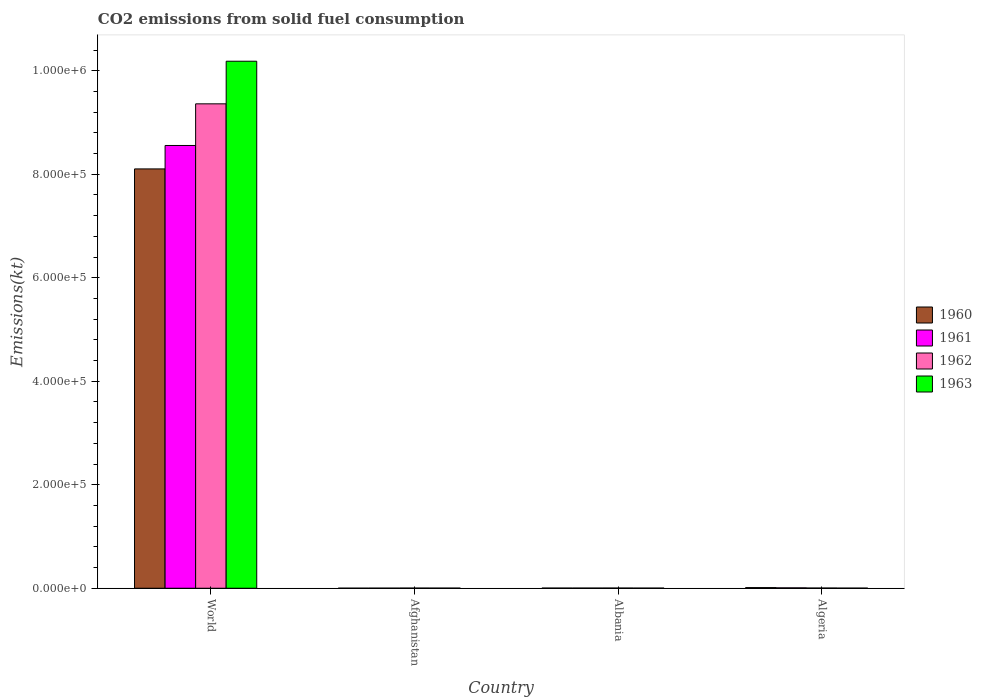How many groups of bars are there?
Keep it short and to the point. 4. Are the number of bars per tick equal to the number of legend labels?
Your answer should be compact. Yes. How many bars are there on the 1st tick from the left?
Make the answer very short. 4. How many bars are there on the 4th tick from the right?
Provide a short and direct response. 4. What is the label of the 2nd group of bars from the left?
Your response must be concise. Afghanistan. In how many cases, is the number of bars for a given country not equal to the number of legend labels?
Your response must be concise. 0. What is the amount of CO2 emitted in 1960 in Albania?
Provide a succinct answer. 326.36. Across all countries, what is the maximum amount of CO2 emitted in 1960?
Provide a short and direct response. 8.10e+05. Across all countries, what is the minimum amount of CO2 emitted in 1961?
Make the answer very short. 176.02. In which country was the amount of CO2 emitted in 1960 minimum?
Make the answer very short. Afghanistan. What is the total amount of CO2 emitted in 1960 in the graph?
Make the answer very short. 8.12e+05. What is the difference between the amount of CO2 emitted in 1960 in Afghanistan and that in Albania?
Ensure brevity in your answer.  -198.02. What is the difference between the amount of CO2 emitted in 1963 in Algeria and the amount of CO2 emitted in 1960 in Albania?
Your response must be concise. -73.34. What is the average amount of CO2 emitted in 1963 per country?
Keep it short and to the point. 2.55e+05. What is the difference between the amount of CO2 emitted of/in 1963 and amount of CO2 emitted of/in 1962 in Algeria?
Provide a short and direct response. -154.01. What is the ratio of the amount of CO2 emitted in 1960 in Albania to that in World?
Your answer should be very brief. 0. Is the amount of CO2 emitted in 1962 in Albania less than that in World?
Provide a short and direct response. Yes. Is the difference between the amount of CO2 emitted in 1963 in Afghanistan and Algeria greater than the difference between the amount of CO2 emitted in 1962 in Afghanistan and Algeria?
Ensure brevity in your answer.  Yes. What is the difference between the highest and the second highest amount of CO2 emitted in 1961?
Your response must be concise. 8.55e+05. What is the difference between the highest and the lowest amount of CO2 emitted in 1963?
Ensure brevity in your answer.  1.02e+06. Is it the case that in every country, the sum of the amount of CO2 emitted in 1961 and amount of CO2 emitted in 1962 is greater than the sum of amount of CO2 emitted in 1963 and amount of CO2 emitted in 1960?
Offer a very short reply. No. What does the 3rd bar from the left in Algeria represents?
Your answer should be very brief. 1962. Are all the bars in the graph horizontal?
Provide a succinct answer. No. How many countries are there in the graph?
Your answer should be compact. 4. Does the graph contain any zero values?
Provide a succinct answer. No. Where does the legend appear in the graph?
Ensure brevity in your answer.  Center right. What is the title of the graph?
Give a very brief answer. CO2 emissions from solid fuel consumption. Does "1982" appear as one of the legend labels in the graph?
Your answer should be very brief. No. What is the label or title of the Y-axis?
Offer a terse response. Emissions(kt). What is the Emissions(kt) in 1960 in World?
Keep it short and to the point. 8.10e+05. What is the Emissions(kt) in 1961 in World?
Your answer should be very brief. 8.56e+05. What is the Emissions(kt) in 1962 in World?
Make the answer very short. 9.36e+05. What is the Emissions(kt) of 1963 in World?
Offer a terse response. 1.02e+06. What is the Emissions(kt) of 1960 in Afghanistan?
Offer a very short reply. 128.34. What is the Emissions(kt) in 1961 in Afghanistan?
Your answer should be compact. 176.02. What is the Emissions(kt) in 1962 in Afghanistan?
Your response must be concise. 297.03. What is the Emissions(kt) of 1963 in Afghanistan?
Your answer should be very brief. 264.02. What is the Emissions(kt) of 1960 in Albania?
Provide a short and direct response. 326.36. What is the Emissions(kt) of 1961 in Albania?
Make the answer very short. 322.7. What is the Emissions(kt) of 1962 in Albania?
Keep it short and to the point. 363.03. What is the Emissions(kt) in 1963 in Albania?
Provide a short and direct response. 282.36. What is the Emissions(kt) in 1960 in Algeria?
Your answer should be compact. 1257.78. What is the Emissions(kt) in 1961 in Algeria?
Make the answer very short. 766.4. What is the Emissions(kt) of 1962 in Algeria?
Keep it short and to the point. 407.04. What is the Emissions(kt) of 1963 in Algeria?
Your answer should be compact. 253.02. Across all countries, what is the maximum Emissions(kt) in 1960?
Provide a short and direct response. 8.10e+05. Across all countries, what is the maximum Emissions(kt) in 1961?
Offer a terse response. 8.56e+05. Across all countries, what is the maximum Emissions(kt) of 1962?
Your response must be concise. 9.36e+05. Across all countries, what is the maximum Emissions(kt) in 1963?
Offer a very short reply. 1.02e+06. Across all countries, what is the minimum Emissions(kt) in 1960?
Make the answer very short. 128.34. Across all countries, what is the minimum Emissions(kt) of 1961?
Keep it short and to the point. 176.02. Across all countries, what is the minimum Emissions(kt) in 1962?
Your response must be concise. 297.03. Across all countries, what is the minimum Emissions(kt) of 1963?
Keep it short and to the point. 253.02. What is the total Emissions(kt) of 1960 in the graph?
Your answer should be very brief. 8.12e+05. What is the total Emissions(kt) of 1961 in the graph?
Give a very brief answer. 8.57e+05. What is the total Emissions(kt) in 1962 in the graph?
Give a very brief answer. 9.37e+05. What is the total Emissions(kt) of 1963 in the graph?
Offer a terse response. 1.02e+06. What is the difference between the Emissions(kt) in 1960 in World and that in Afghanistan?
Provide a short and direct response. 8.10e+05. What is the difference between the Emissions(kt) in 1961 in World and that in Afghanistan?
Give a very brief answer. 8.55e+05. What is the difference between the Emissions(kt) in 1962 in World and that in Afghanistan?
Your response must be concise. 9.36e+05. What is the difference between the Emissions(kt) of 1963 in World and that in Afghanistan?
Provide a short and direct response. 1.02e+06. What is the difference between the Emissions(kt) in 1960 in World and that in Albania?
Offer a very short reply. 8.10e+05. What is the difference between the Emissions(kt) in 1961 in World and that in Albania?
Offer a terse response. 8.55e+05. What is the difference between the Emissions(kt) of 1962 in World and that in Albania?
Your answer should be very brief. 9.36e+05. What is the difference between the Emissions(kt) of 1963 in World and that in Albania?
Provide a succinct answer. 1.02e+06. What is the difference between the Emissions(kt) of 1960 in World and that in Algeria?
Keep it short and to the point. 8.09e+05. What is the difference between the Emissions(kt) of 1961 in World and that in Algeria?
Your response must be concise. 8.55e+05. What is the difference between the Emissions(kt) of 1962 in World and that in Algeria?
Offer a very short reply. 9.36e+05. What is the difference between the Emissions(kt) of 1963 in World and that in Algeria?
Provide a succinct answer. 1.02e+06. What is the difference between the Emissions(kt) of 1960 in Afghanistan and that in Albania?
Ensure brevity in your answer.  -198.02. What is the difference between the Emissions(kt) in 1961 in Afghanistan and that in Albania?
Make the answer very short. -146.68. What is the difference between the Emissions(kt) in 1962 in Afghanistan and that in Albania?
Make the answer very short. -66.01. What is the difference between the Emissions(kt) in 1963 in Afghanistan and that in Albania?
Ensure brevity in your answer.  -18.34. What is the difference between the Emissions(kt) of 1960 in Afghanistan and that in Algeria?
Provide a succinct answer. -1129.44. What is the difference between the Emissions(kt) of 1961 in Afghanistan and that in Algeria?
Keep it short and to the point. -590.39. What is the difference between the Emissions(kt) in 1962 in Afghanistan and that in Algeria?
Your response must be concise. -110.01. What is the difference between the Emissions(kt) in 1963 in Afghanistan and that in Algeria?
Your response must be concise. 11. What is the difference between the Emissions(kt) of 1960 in Albania and that in Algeria?
Offer a terse response. -931.42. What is the difference between the Emissions(kt) of 1961 in Albania and that in Algeria?
Keep it short and to the point. -443.71. What is the difference between the Emissions(kt) in 1962 in Albania and that in Algeria?
Your answer should be compact. -44. What is the difference between the Emissions(kt) of 1963 in Albania and that in Algeria?
Your answer should be compact. 29.34. What is the difference between the Emissions(kt) in 1960 in World and the Emissions(kt) in 1961 in Afghanistan?
Your answer should be very brief. 8.10e+05. What is the difference between the Emissions(kt) in 1960 in World and the Emissions(kt) in 1962 in Afghanistan?
Your response must be concise. 8.10e+05. What is the difference between the Emissions(kt) in 1960 in World and the Emissions(kt) in 1963 in Afghanistan?
Your answer should be compact. 8.10e+05. What is the difference between the Emissions(kt) in 1961 in World and the Emissions(kt) in 1962 in Afghanistan?
Make the answer very short. 8.55e+05. What is the difference between the Emissions(kt) of 1961 in World and the Emissions(kt) of 1963 in Afghanistan?
Your response must be concise. 8.55e+05. What is the difference between the Emissions(kt) of 1962 in World and the Emissions(kt) of 1963 in Afghanistan?
Your response must be concise. 9.36e+05. What is the difference between the Emissions(kt) in 1960 in World and the Emissions(kt) in 1961 in Albania?
Keep it short and to the point. 8.10e+05. What is the difference between the Emissions(kt) of 1960 in World and the Emissions(kt) of 1962 in Albania?
Your answer should be very brief. 8.10e+05. What is the difference between the Emissions(kt) of 1960 in World and the Emissions(kt) of 1963 in Albania?
Give a very brief answer. 8.10e+05. What is the difference between the Emissions(kt) in 1961 in World and the Emissions(kt) in 1962 in Albania?
Keep it short and to the point. 8.55e+05. What is the difference between the Emissions(kt) in 1961 in World and the Emissions(kt) in 1963 in Albania?
Offer a very short reply. 8.55e+05. What is the difference between the Emissions(kt) of 1962 in World and the Emissions(kt) of 1963 in Albania?
Offer a terse response. 9.36e+05. What is the difference between the Emissions(kt) of 1960 in World and the Emissions(kt) of 1961 in Algeria?
Ensure brevity in your answer.  8.10e+05. What is the difference between the Emissions(kt) of 1960 in World and the Emissions(kt) of 1962 in Algeria?
Your answer should be very brief. 8.10e+05. What is the difference between the Emissions(kt) in 1960 in World and the Emissions(kt) in 1963 in Algeria?
Provide a succinct answer. 8.10e+05. What is the difference between the Emissions(kt) of 1961 in World and the Emissions(kt) of 1962 in Algeria?
Ensure brevity in your answer.  8.55e+05. What is the difference between the Emissions(kt) of 1961 in World and the Emissions(kt) of 1963 in Algeria?
Your answer should be compact. 8.55e+05. What is the difference between the Emissions(kt) of 1962 in World and the Emissions(kt) of 1963 in Algeria?
Provide a short and direct response. 9.36e+05. What is the difference between the Emissions(kt) in 1960 in Afghanistan and the Emissions(kt) in 1961 in Albania?
Offer a very short reply. -194.35. What is the difference between the Emissions(kt) of 1960 in Afghanistan and the Emissions(kt) of 1962 in Albania?
Your answer should be very brief. -234.69. What is the difference between the Emissions(kt) of 1960 in Afghanistan and the Emissions(kt) of 1963 in Albania?
Your answer should be compact. -154.01. What is the difference between the Emissions(kt) in 1961 in Afghanistan and the Emissions(kt) in 1962 in Albania?
Make the answer very short. -187.02. What is the difference between the Emissions(kt) of 1961 in Afghanistan and the Emissions(kt) of 1963 in Albania?
Make the answer very short. -106.34. What is the difference between the Emissions(kt) in 1962 in Afghanistan and the Emissions(kt) in 1963 in Albania?
Make the answer very short. 14.67. What is the difference between the Emissions(kt) in 1960 in Afghanistan and the Emissions(kt) in 1961 in Algeria?
Provide a succinct answer. -638.06. What is the difference between the Emissions(kt) of 1960 in Afghanistan and the Emissions(kt) of 1962 in Algeria?
Offer a very short reply. -278.69. What is the difference between the Emissions(kt) of 1960 in Afghanistan and the Emissions(kt) of 1963 in Algeria?
Offer a terse response. -124.68. What is the difference between the Emissions(kt) in 1961 in Afghanistan and the Emissions(kt) in 1962 in Algeria?
Provide a succinct answer. -231.02. What is the difference between the Emissions(kt) of 1961 in Afghanistan and the Emissions(kt) of 1963 in Algeria?
Make the answer very short. -77.01. What is the difference between the Emissions(kt) in 1962 in Afghanistan and the Emissions(kt) in 1963 in Algeria?
Make the answer very short. 44. What is the difference between the Emissions(kt) of 1960 in Albania and the Emissions(kt) of 1961 in Algeria?
Your answer should be compact. -440.04. What is the difference between the Emissions(kt) of 1960 in Albania and the Emissions(kt) of 1962 in Algeria?
Offer a very short reply. -80.67. What is the difference between the Emissions(kt) of 1960 in Albania and the Emissions(kt) of 1963 in Algeria?
Offer a very short reply. 73.34. What is the difference between the Emissions(kt) of 1961 in Albania and the Emissions(kt) of 1962 in Algeria?
Make the answer very short. -84.34. What is the difference between the Emissions(kt) in 1961 in Albania and the Emissions(kt) in 1963 in Algeria?
Your response must be concise. 69.67. What is the difference between the Emissions(kt) of 1962 in Albania and the Emissions(kt) of 1963 in Algeria?
Offer a very short reply. 110.01. What is the average Emissions(kt) in 1960 per country?
Your response must be concise. 2.03e+05. What is the average Emissions(kt) of 1961 per country?
Give a very brief answer. 2.14e+05. What is the average Emissions(kt) in 1962 per country?
Your answer should be very brief. 2.34e+05. What is the average Emissions(kt) of 1963 per country?
Offer a very short reply. 2.55e+05. What is the difference between the Emissions(kt) in 1960 and Emissions(kt) in 1961 in World?
Keep it short and to the point. -4.53e+04. What is the difference between the Emissions(kt) of 1960 and Emissions(kt) of 1962 in World?
Offer a very short reply. -1.26e+05. What is the difference between the Emissions(kt) in 1960 and Emissions(kt) in 1963 in World?
Give a very brief answer. -2.08e+05. What is the difference between the Emissions(kt) of 1961 and Emissions(kt) of 1962 in World?
Keep it short and to the point. -8.05e+04. What is the difference between the Emissions(kt) of 1961 and Emissions(kt) of 1963 in World?
Ensure brevity in your answer.  -1.63e+05. What is the difference between the Emissions(kt) of 1962 and Emissions(kt) of 1963 in World?
Your answer should be compact. -8.24e+04. What is the difference between the Emissions(kt) of 1960 and Emissions(kt) of 1961 in Afghanistan?
Provide a succinct answer. -47.67. What is the difference between the Emissions(kt) in 1960 and Emissions(kt) in 1962 in Afghanistan?
Offer a very short reply. -168.68. What is the difference between the Emissions(kt) of 1960 and Emissions(kt) of 1963 in Afghanistan?
Provide a succinct answer. -135.68. What is the difference between the Emissions(kt) of 1961 and Emissions(kt) of 1962 in Afghanistan?
Offer a terse response. -121.01. What is the difference between the Emissions(kt) in 1961 and Emissions(kt) in 1963 in Afghanistan?
Offer a terse response. -88.01. What is the difference between the Emissions(kt) in 1962 and Emissions(kt) in 1963 in Afghanistan?
Your answer should be compact. 33. What is the difference between the Emissions(kt) in 1960 and Emissions(kt) in 1961 in Albania?
Provide a short and direct response. 3.67. What is the difference between the Emissions(kt) of 1960 and Emissions(kt) of 1962 in Albania?
Provide a short and direct response. -36.67. What is the difference between the Emissions(kt) in 1960 and Emissions(kt) in 1963 in Albania?
Provide a short and direct response. 44. What is the difference between the Emissions(kt) in 1961 and Emissions(kt) in 1962 in Albania?
Ensure brevity in your answer.  -40.34. What is the difference between the Emissions(kt) of 1961 and Emissions(kt) of 1963 in Albania?
Provide a succinct answer. 40.34. What is the difference between the Emissions(kt) in 1962 and Emissions(kt) in 1963 in Albania?
Offer a terse response. 80.67. What is the difference between the Emissions(kt) in 1960 and Emissions(kt) in 1961 in Algeria?
Your answer should be compact. 491.38. What is the difference between the Emissions(kt) of 1960 and Emissions(kt) of 1962 in Algeria?
Keep it short and to the point. 850.74. What is the difference between the Emissions(kt) in 1960 and Emissions(kt) in 1963 in Algeria?
Your answer should be compact. 1004.76. What is the difference between the Emissions(kt) of 1961 and Emissions(kt) of 1962 in Algeria?
Offer a very short reply. 359.37. What is the difference between the Emissions(kt) in 1961 and Emissions(kt) in 1963 in Algeria?
Your answer should be very brief. 513.38. What is the difference between the Emissions(kt) in 1962 and Emissions(kt) in 1963 in Algeria?
Give a very brief answer. 154.01. What is the ratio of the Emissions(kt) of 1960 in World to that in Afghanistan?
Your answer should be very brief. 6313.69. What is the ratio of the Emissions(kt) in 1961 in World to that in Afghanistan?
Make the answer very short. 4860.98. What is the ratio of the Emissions(kt) of 1962 in World to that in Afghanistan?
Give a very brief answer. 3151.44. What is the ratio of the Emissions(kt) in 1963 in World to that in Afghanistan?
Ensure brevity in your answer.  3857.29. What is the ratio of the Emissions(kt) in 1960 in World to that in Albania?
Offer a very short reply. 2482.91. What is the ratio of the Emissions(kt) of 1961 in World to that in Albania?
Provide a short and direct response. 2651.44. What is the ratio of the Emissions(kt) in 1962 in World to that in Albania?
Ensure brevity in your answer.  2578.45. What is the ratio of the Emissions(kt) of 1963 in World to that in Albania?
Keep it short and to the point. 3606.82. What is the ratio of the Emissions(kt) of 1960 in World to that in Algeria?
Provide a short and direct response. 644.25. What is the ratio of the Emissions(kt) of 1961 in World to that in Algeria?
Offer a terse response. 1116.4. What is the ratio of the Emissions(kt) of 1962 in World to that in Algeria?
Make the answer very short. 2299.7. What is the ratio of the Emissions(kt) of 1963 in World to that in Algeria?
Make the answer very short. 4025. What is the ratio of the Emissions(kt) of 1960 in Afghanistan to that in Albania?
Offer a terse response. 0.39. What is the ratio of the Emissions(kt) in 1961 in Afghanistan to that in Albania?
Provide a short and direct response. 0.55. What is the ratio of the Emissions(kt) of 1962 in Afghanistan to that in Albania?
Provide a succinct answer. 0.82. What is the ratio of the Emissions(kt) of 1963 in Afghanistan to that in Albania?
Provide a succinct answer. 0.94. What is the ratio of the Emissions(kt) in 1960 in Afghanistan to that in Algeria?
Your answer should be compact. 0.1. What is the ratio of the Emissions(kt) in 1961 in Afghanistan to that in Algeria?
Provide a short and direct response. 0.23. What is the ratio of the Emissions(kt) of 1962 in Afghanistan to that in Algeria?
Keep it short and to the point. 0.73. What is the ratio of the Emissions(kt) of 1963 in Afghanistan to that in Algeria?
Ensure brevity in your answer.  1.04. What is the ratio of the Emissions(kt) in 1960 in Albania to that in Algeria?
Give a very brief answer. 0.26. What is the ratio of the Emissions(kt) in 1961 in Albania to that in Algeria?
Ensure brevity in your answer.  0.42. What is the ratio of the Emissions(kt) of 1962 in Albania to that in Algeria?
Your response must be concise. 0.89. What is the ratio of the Emissions(kt) in 1963 in Albania to that in Algeria?
Keep it short and to the point. 1.12. What is the difference between the highest and the second highest Emissions(kt) of 1960?
Give a very brief answer. 8.09e+05. What is the difference between the highest and the second highest Emissions(kt) in 1961?
Keep it short and to the point. 8.55e+05. What is the difference between the highest and the second highest Emissions(kt) in 1962?
Your answer should be very brief. 9.36e+05. What is the difference between the highest and the second highest Emissions(kt) of 1963?
Make the answer very short. 1.02e+06. What is the difference between the highest and the lowest Emissions(kt) in 1960?
Provide a short and direct response. 8.10e+05. What is the difference between the highest and the lowest Emissions(kt) of 1961?
Offer a terse response. 8.55e+05. What is the difference between the highest and the lowest Emissions(kt) of 1962?
Your answer should be very brief. 9.36e+05. What is the difference between the highest and the lowest Emissions(kt) in 1963?
Ensure brevity in your answer.  1.02e+06. 